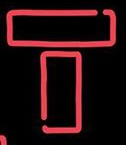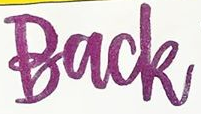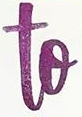Read the text from these images in sequence, separated by a semicolon. T; Back; to 